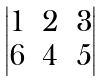<formula> <loc_0><loc_0><loc_500><loc_500>\begin{vmatrix} 1 & 2 & 3 \\ 6 & 4 & 5 \end{vmatrix}</formula> 